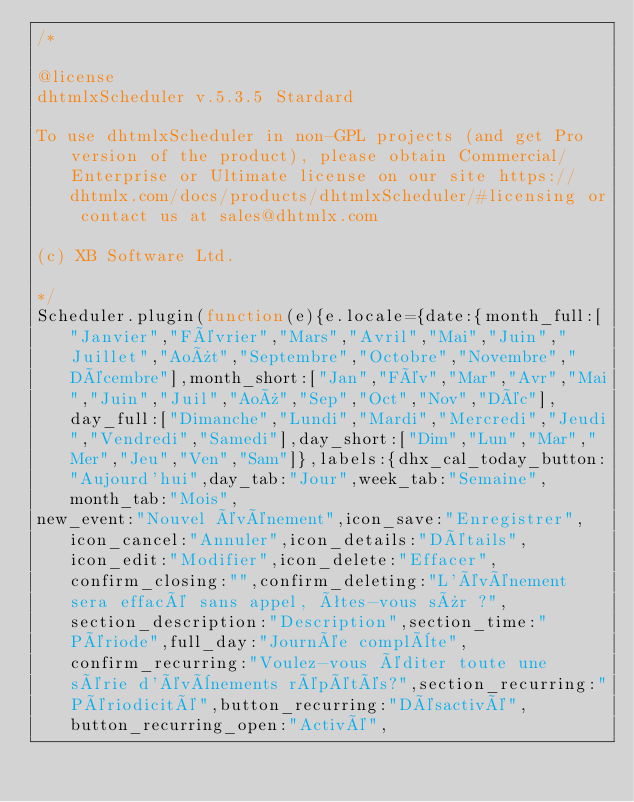Convert code to text. <code><loc_0><loc_0><loc_500><loc_500><_JavaScript_>/*

@license
dhtmlxScheduler v.5.3.5 Stardard

To use dhtmlxScheduler in non-GPL projects (and get Pro version of the product), please obtain Commercial/Enterprise or Ultimate license on our site https://dhtmlx.com/docs/products/dhtmlxScheduler/#licensing or contact us at sales@dhtmlx.com

(c) XB Software Ltd.

*/
Scheduler.plugin(function(e){e.locale={date:{month_full:["Janvier","Février","Mars","Avril","Mai","Juin","Juillet","Août","Septembre","Octobre","Novembre","Décembre"],month_short:["Jan","Fév","Mar","Avr","Mai","Juin","Juil","Aoû","Sep","Oct","Nov","Déc"],day_full:["Dimanche","Lundi","Mardi","Mercredi","Jeudi","Vendredi","Samedi"],day_short:["Dim","Lun","Mar","Mer","Jeu","Ven","Sam"]},labels:{dhx_cal_today_button:"Aujourd'hui",day_tab:"Jour",week_tab:"Semaine",month_tab:"Mois",
new_event:"Nouvel événement",icon_save:"Enregistrer",icon_cancel:"Annuler",icon_details:"Détails",icon_edit:"Modifier",icon_delete:"Effacer",confirm_closing:"",confirm_deleting:"L'événement sera effacé sans appel, êtes-vous sûr ?",section_description:"Description",section_time:"Période",full_day:"Journée complète",confirm_recurring:"Voulez-vous éditer toute une série d'évènements répétés?",section_recurring:"Périodicité",button_recurring:"Désactivé",button_recurring_open:"Activé",</code> 